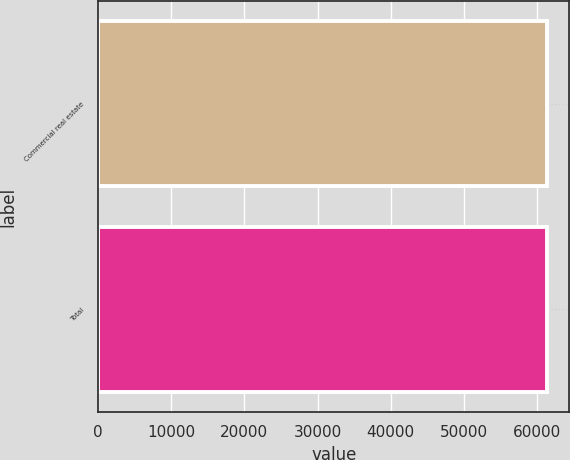<chart> <loc_0><loc_0><loc_500><loc_500><bar_chart><fcel>Commercial real estate<fcel>Total<nl><fcel>61361<fcel>61361.1<nl></chart> 